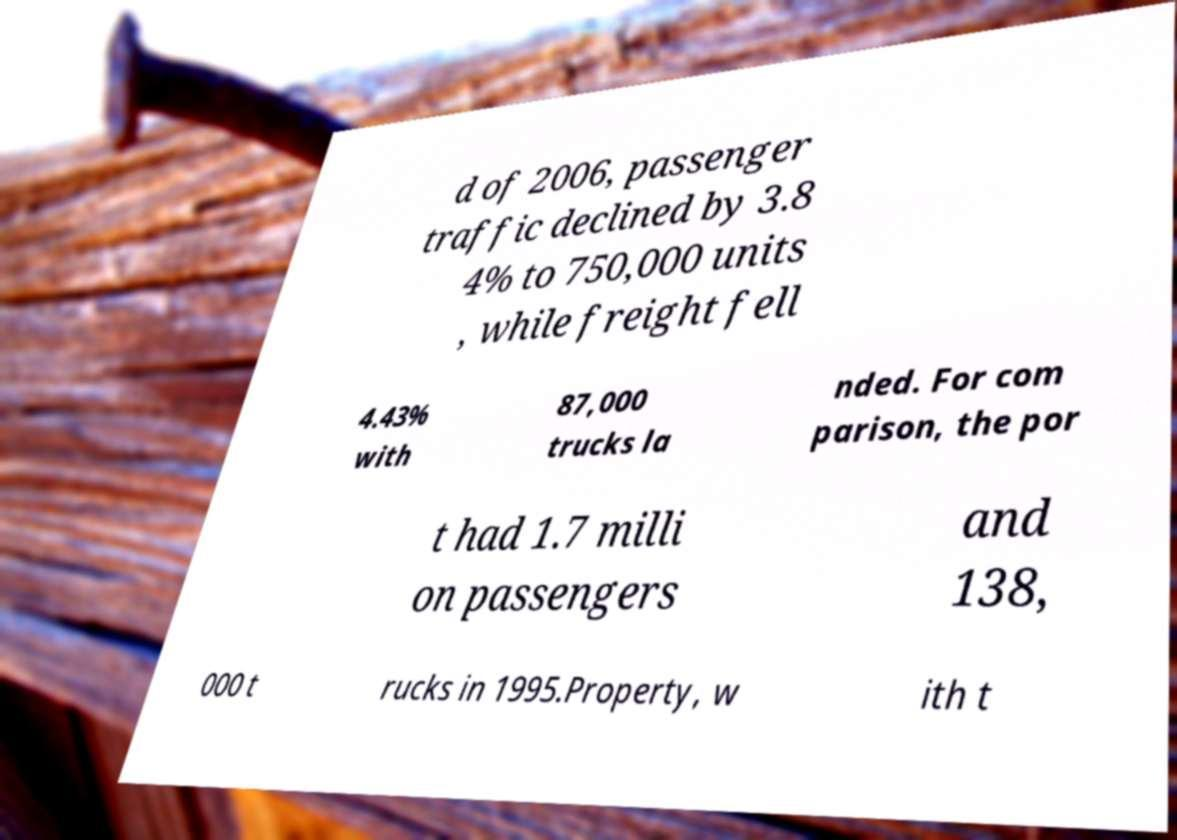Please read and relay the text visible in this image. What does it say? d of 2006, passenger traffic declined by 3.8 4% to 750,000 units , while freight fell 4.43% with 87,000 trucks la nded. For com parison, the por t had 1.7 milli on passengers and 138, 000 t rucks in 1995.Property, w ith t 